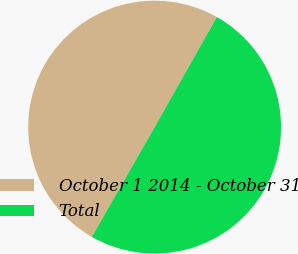Convert chart to OTSL. <chart><loc_0><loc_0><loc_500><loc_500><pie_chart><fcel>October 1 2014 - October 31<fcel>Total<nl><fcel>49.91%<fcel>50.09%<nl></chart> 